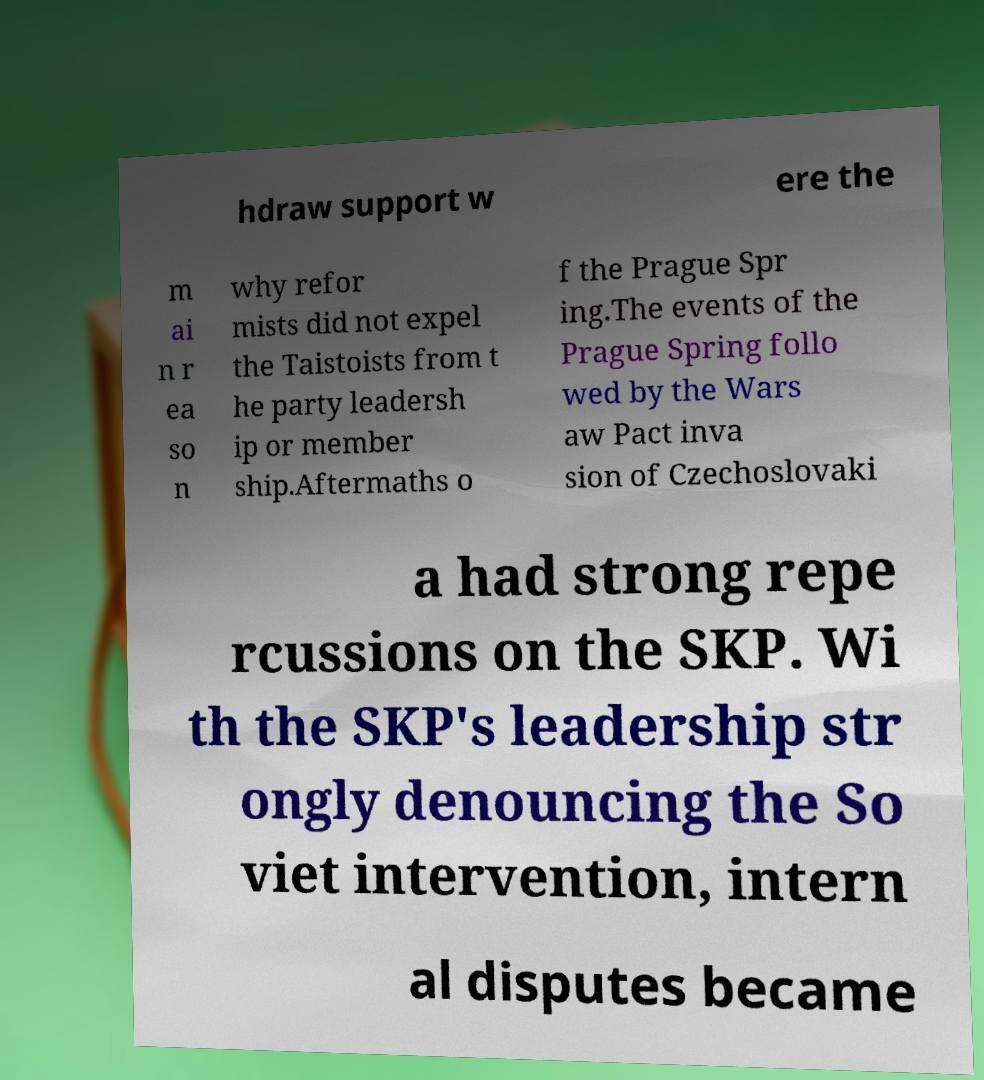What messages or text are displayed in this image? I need them in a readable, typed format. hdraw support w ere the m ai n r ea so n why refor mists did not expel the Taistoists from t he party leadersh ip or member ship.Aftermaths o f the Prague Spr ing.The events of the Prague Spring follo wed by the Wars aw Pact inva sion of Czechoslovaki a had strong repe rcussions on the SKP. Wi th the SKP's leadership str ongly denouncing the So viet intervention, intern al disputes became 